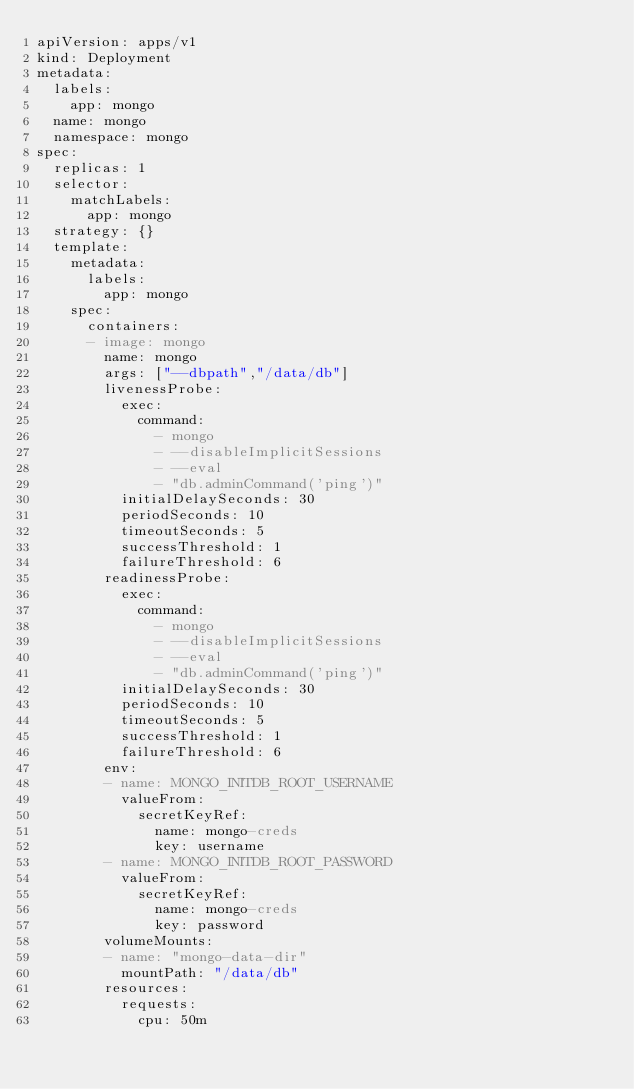<code> <loc_0><loc_0><loc_500><loc_500><_YAML_>apiVersion: apps/v1
kind: Deployment
metadata:
  labels:
    app: mongo
  name: mongo
  namespace: mongo
spec:
  replicas: 1
  selector:
    matchLabels:
      app: mongo
  strategy: {}
  template:
    metadata:
      labels:
        app: mongo
    spec:
      containers:
      - image: mongo
        name: mongo
        args: ["--dbpath","/data/db"]
        livenessProbe:
          exec:
            command:
              - mongo
              - --disableImplicitSessions
              - --eval
              - "db.adminCommand('ping')"
          initialDelaySeconds: 30
          periodSeconds: 10
          timeoutSeconds: 5
          successThreshold: 1
          failureThreshold: 6
        readinessProbe:
          exec:
            command:
              - mongo
              - --disableImplicitSessions
              - --eval
              - "db.adminCommand('ping')"
          initialDelaySeconds: 30
          periodSeconds: 10
          timeoutSeconds: 5
          successThreshold: 1
          failureThreshold: 6
        env:
        - name: MONGO_INITDB_ROOT_USERNAME
          valueFrom:
            secretKeyRef:
              name: mongo-creds
              key: username
        - name: MONGO_INITDB_ROOT_PASSWORD
          valueFrom:
            secretKeyRef:
              name: mongo-creds
              key: password
        volumeMounts:
        - name: "mongo-data-dir"
          mountPath: "/data/db"
        resources:
          requests:
            cpu: 50m</code> 